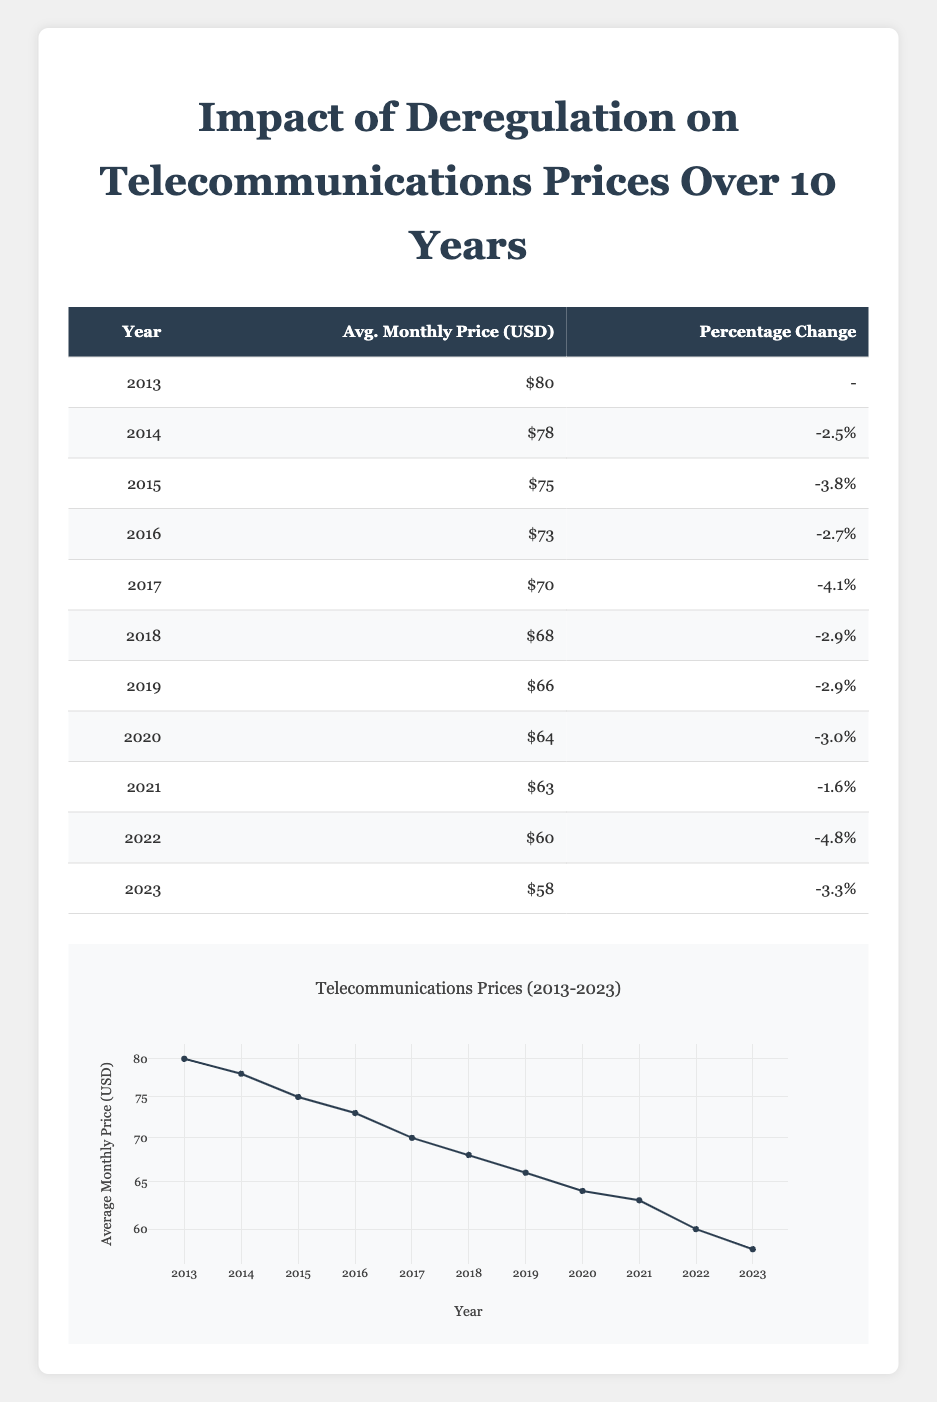What was the average monthly price in 2015? According to the table, the average monthly price for 2015 is listed under the "Avg. Monthly Price (USD)" column, which shows $75.
Answer: 75 What is the percentage change in monthly price from 2016 to 2017? To find the percentage change from 2016 to 2017, we look at the "Percentage Change" for those years. In 2016, it is -2.7%, and in 2017, it is -4.1%. This indicates a change of -1.4%.
Answer: -1.4% Was the average monthly price higher in 2013 than in 2023? From the table, we see that the average monthly price in 2013 is $80 and in 2023 is $58. Since $80 is greater than $58, the statement is true.
Answer: Yes What was the total change in average monthly price from 2013 to 2023? The average monthly price in 2013 is $80 and in 2023 is $58. To calculate the total change, we subtract: 80 - 58 = 22. Therefore, the total change is a decrease of $22.
Answer: 22 Which year saw the greatest percentage reduction in average monthly price? We will look at the "Percentage Change" column for all years. The year with the highest negative percentage is 2022 with -4.8%. Therefore, 2022 saw the greatest reduction.
Answer: 2022 What was the average monthly price over these 10 years? To find the average monthly price over the 10 years, we sum all the monthly prices and divide by 11 (the years from 2013 to 2023). The sum is 80 + 78 + 75 + 73 + 70 + 68 + 66 + 64 + 63 + 60 + 58 =  785. Therefore, the average is 785 / 11 ≈ 71.36.
Answer: 71.36 Is there a consistent trend in percentage changes from 2014 to 2023? We observe the "Percentage Change" column from 2014 to 2023. The values decrease most years, indicating a trend toward reduction in prices. However, we see a smaller percentage change in 2021 (-1.6%) which breaks the consistent downward trend slightly, but overall, the trend is negative.
Answer: Yes What was the average percentage change from 2013 to 2023? To find the average percentage change from 2014 to 2023, we need to consider the percentage changes for those years: -2.5%, -3.8%, -2.7%, -4.1%, -2.9%, -2.9%, -3.0%, -1.6%, -4.8%, and -3.3%. Summing these values gives a total of -24.7% and dividing by 10 yields an average of -2.47%.
Answer: -2.47% 